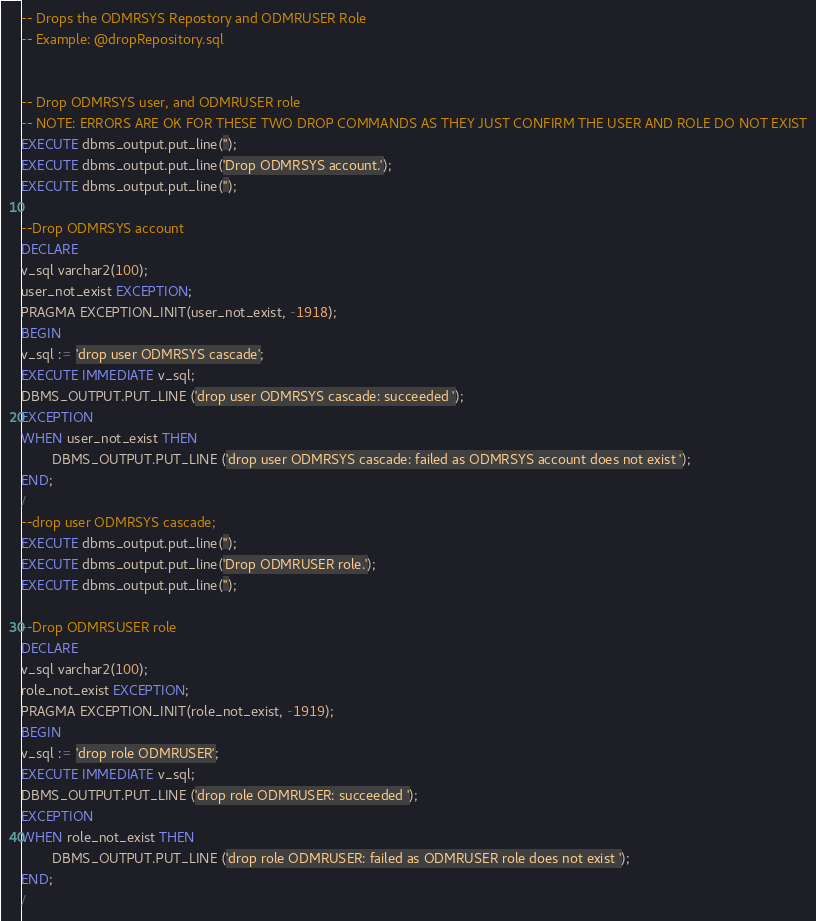<code> <loc_0><loc_0><loc_500><loc_500><_SQL_>-- Drops the ODMRSYS Repostory and ODMRUSER Role
-- Example: @dropRepository.sql 


-- Drop ODMRSYS user, and ODMRUSER role
-- NOTE: ERRORS ARE OK FOR THESE TWO DROP COMMANDS AS THEY JUST CONFIRM THE USER AND ROLE DO NOT EXIST
EXECUTE dbms_output.put_line('');
EXECUTE dbms_output.put_line('Drop ODMRSYS account.');
EXECUTE dbms_output.put_line('');

--Drop ODMRSYS account
DECLARE
v_sql varchar2(100); 
user_not_exist EXCEPTION;
PRAGMA EXCEPTION_INIT(user_not_exist, -1918);
BEGIN
v_sql := 'drop user ODMRSYS cascade';
EXECUTE IMMEDIATE v_sql;
DBMS_OUTPUT.PUT_LINE ('drop user ODMRSYS cascade: succeeded ');
EXCEPTION
WHEN user_not_exist THEN
        DBMS_OUTPUT.PUT_LINE ('drop user ODMRSYS cascade: failed as ODMRSYS account does not exist ');
END;
/
--drop user ODMRSYS cascade;
EXECUTE dbms_output.put_line('');
EXECUTE dbms_output.put_line('Drop ODMRUSER role.');
EXECUTE dbms_output.put_line('');

--Drop ODMRSUSER role
DECLARE
v_sql varchar2(100); 
role_not_exist EXCEPTION;
PRAGMA EXCEPTION_INIT(role_not_exist, -1919);
BEGIN
v_sql := 'drop role ODMRUSER';
EXECUTE IMMEDIATE v_sql;
DBMS_OUTPUT.PUT_LINE ('drop role ODMRUSER: succeeded ');
EXCEPTION
WHEN role_not_exist THEN
        DBMS_OUTPUT.PUT_LINE ('drop role ODMRUSER: failed as ODMRUSER role does not exist ');
END;
/


</code> 